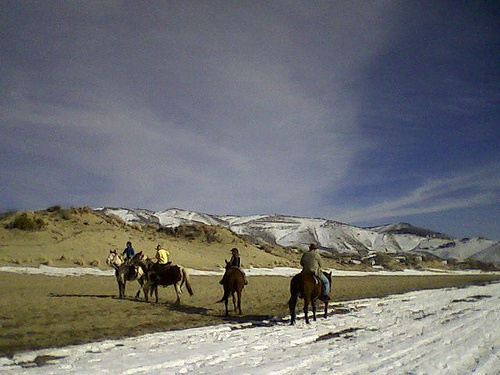Describe the objects in this image and their specific colors. I can see horse in blue, black, olive, and tan tones, horse in blue, black, gray, and darkgreen tones, horse in blue, black, olive, and tan tones, horse in blue, black, olive, and gray tones, and people in blue, black, gray, darkgreen, and olive tones in this image. 